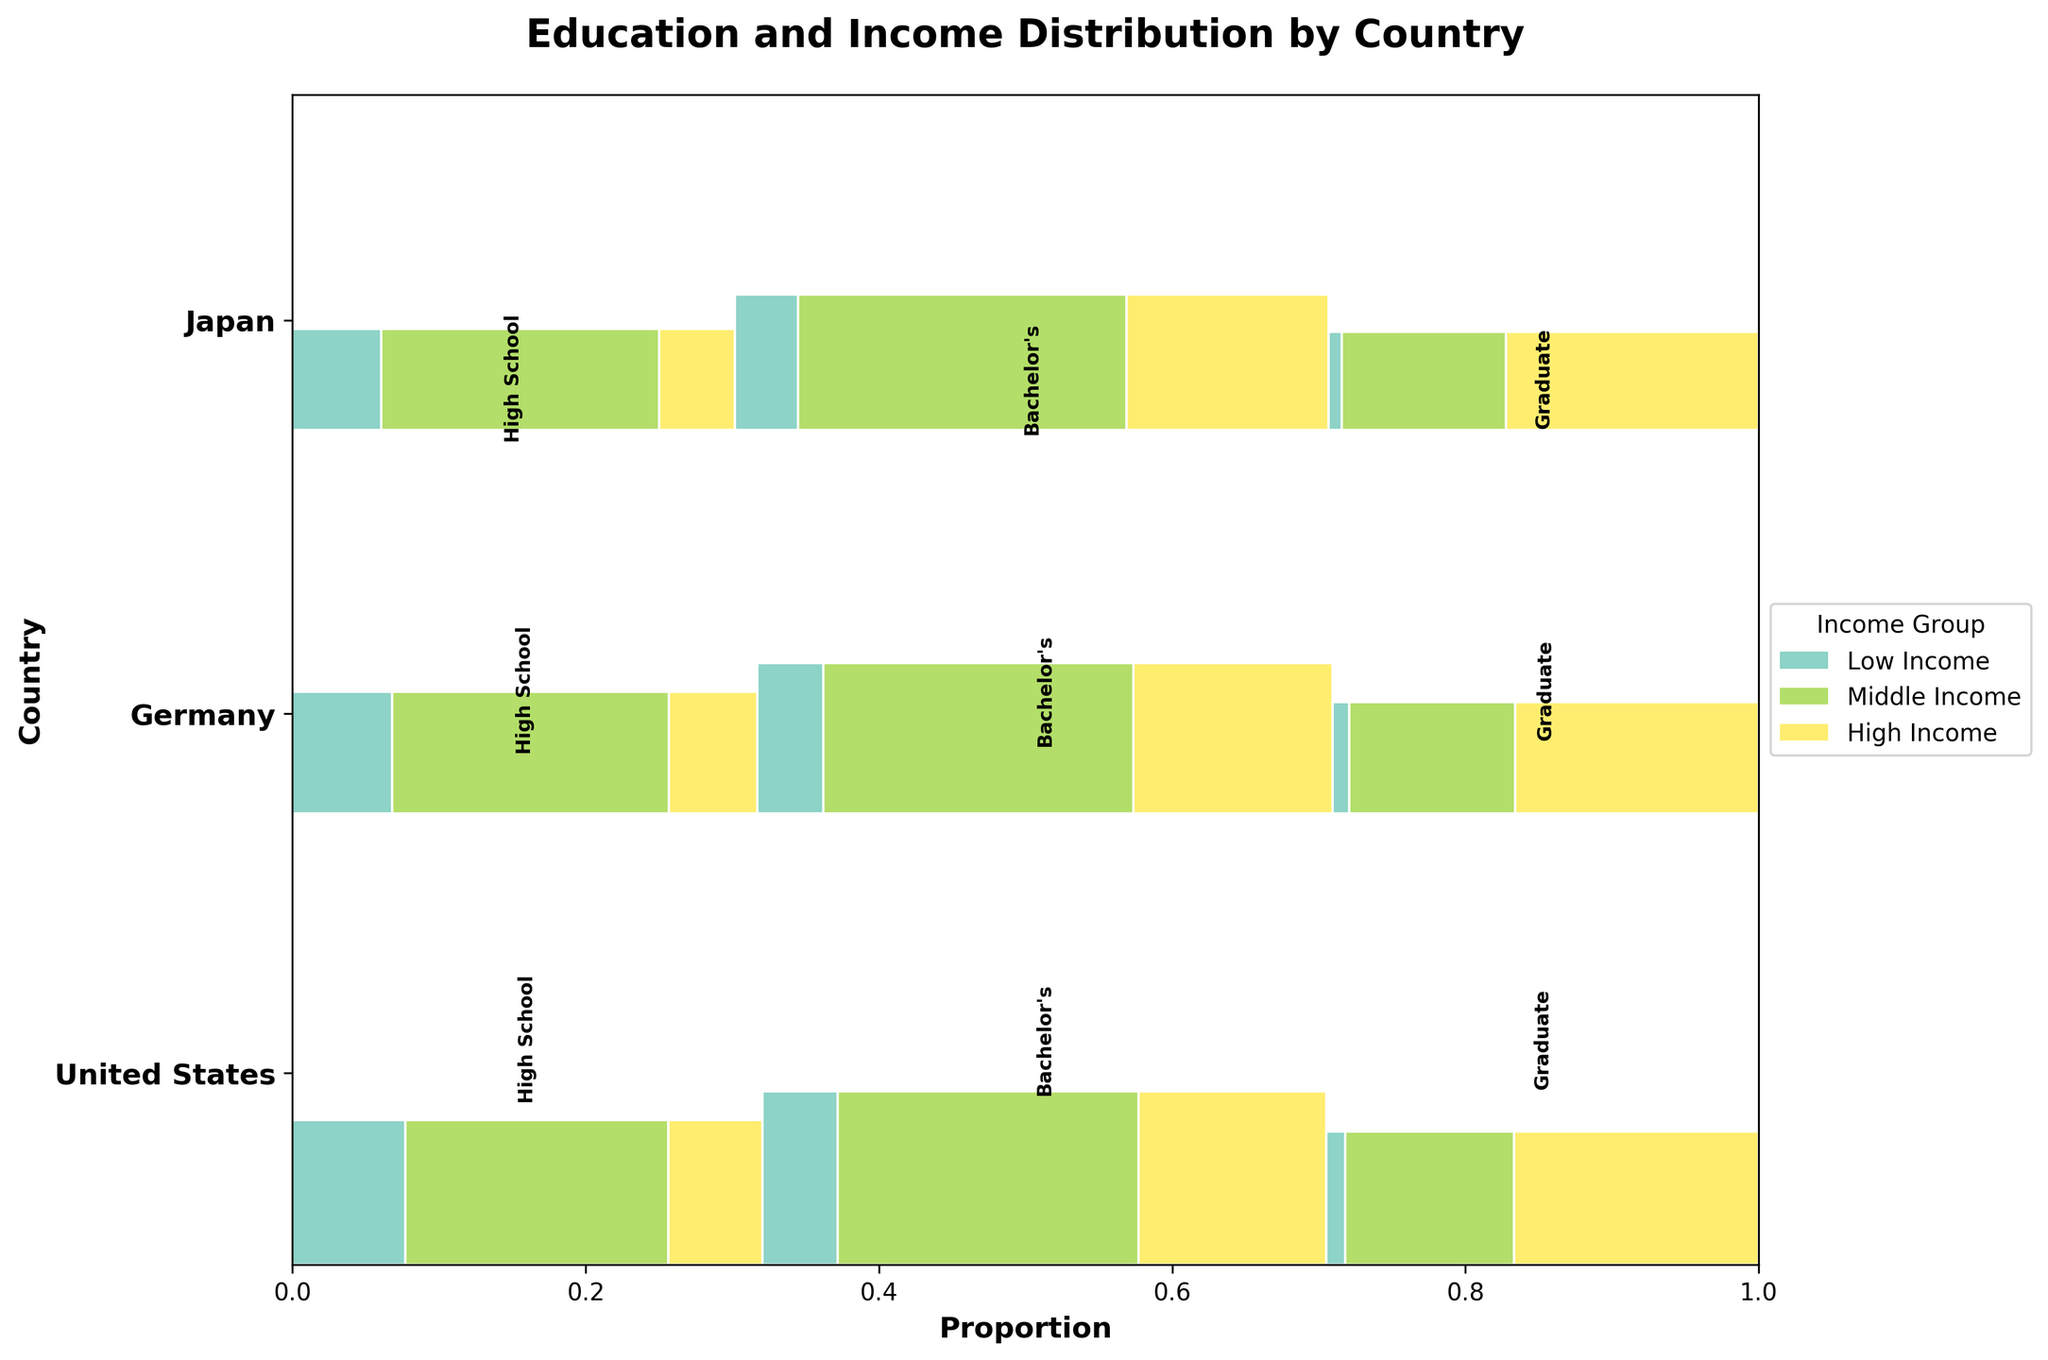What is the overall structure and title of the figure? The figure is a Mosaic Plot with a title that reads 'Education and Income Distribution by Country'. The x-axis represents the proportion, and the y-axis lists the countries. There are colored segments representing different income groups.
Answer: Education and Income Distribution by Country Which country shows the highest proportion of individuals who have a graduate education and fall into the high-income group? By examining the segments within each country, the United States has the largest segment for individuals with a graduate education and high income, as indicated by the substantial width and height of this segment relative to its counterparts.
Answer: United States How does the distribution of middle-income individuals compare between those with a high school education and those with a graduate education within Japan? In the Mosaic Plot, within Japan, the width of the middle-income segment for high school graduates is larger than the width for graduate education, indicating a higher proportion of middle-income individuals among high school graduates.
Answer: High school > Graduate education What is the difference in the proportion of low-income individuals with a Bachelor's degree between Germany and the United States? To determine this, observe the segments for low-income individuals with a Bachelor's degree in both countries. The segment for Germany is thinner than that for the United States, meaning Germany has a lower proportion.
Answer: United States has a higher proportion Across all countries, which education level has the smallest proportion of individuals in the low-income group? By comparing the low-income segments across all countries and educational levels, it is evident that individuals with a Graduate education have the smallest proportional segments for low income.
Answer: Graduate education In Germany, which income group has the largest proportion among individuals with a Bachelor's degree? Looking at the segments within Germany for those with a Bachelor's degree, the middle-income group segment is the largest, indicating the highest proportion.
Answer: Middle income Considering the overall plot, which income group is least represented among those with high school education? Observing all the segments representing high school education across countries, the segments are smallest for the high-income group.
Answer: High income Which country has the highest overall proportion of low-income individuals regardless of education level? By examining the heights of the low-income segments across all countries, the United States has the largest cumulative height, indicating the highest proportion of low-income individuals.
Answer: United States What is the relative proportion of individuals with a bachelor's education and middle income when comparing Japan and Germany? In the Mosaic Plot, the middle-income segment for individuals with a Bachelor's degree is larger in Germany than in Japan, indicating Germany has a higher proportion.
Answer: Germany Which country shows the most balanced distribution across income groups for those with graduate education? By comparing the segments within each country for those with graduate education, Japan shows relatively balanced segment widths for low, middle, and high-income groups.
Answer: Japan 